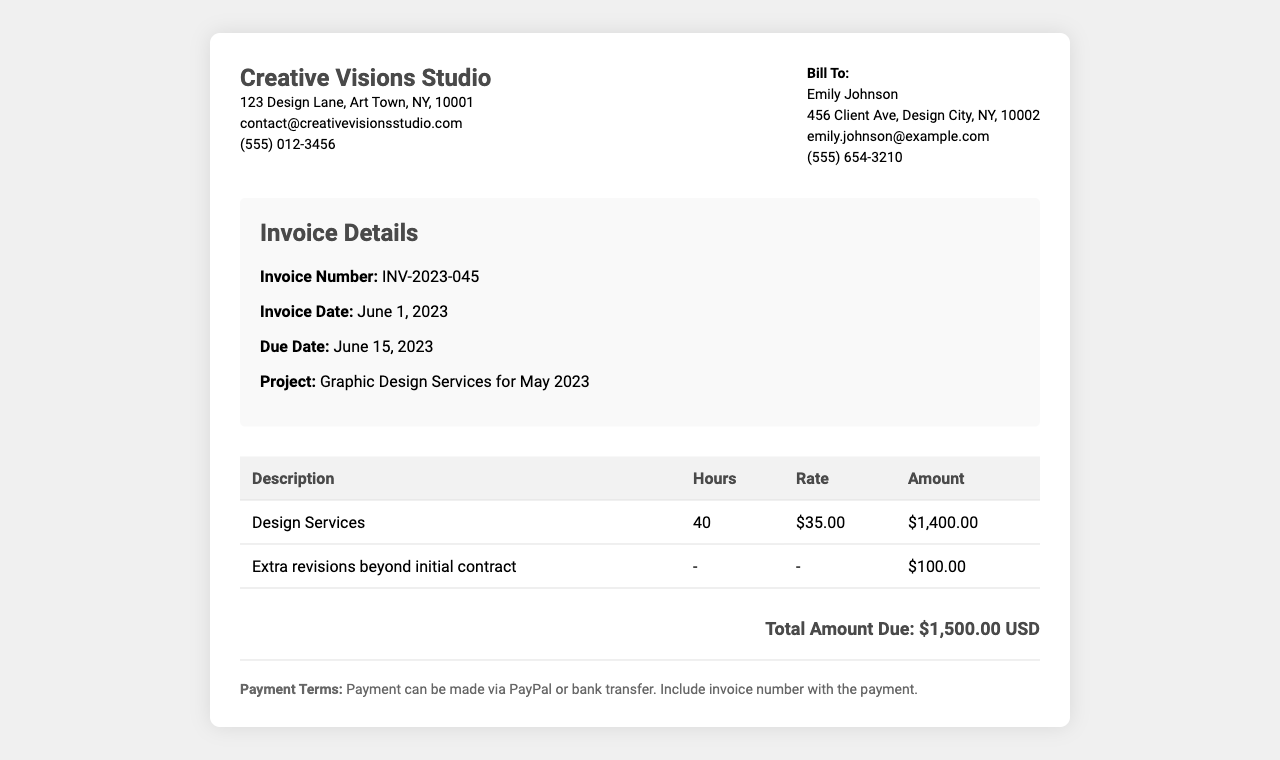What is the invoice number? The invoice number is specified in the document under "Invoice Details".
Answer: INV-2023-045 Who is the client? The client's name is listed in the "Bill To" section of the invoice.
Answer: Emily Johnson What is the due date of the invoice? The due date is mentioned in the "Invoice Details" section.
Answer: June 15, 2023 How many hours were worked for design services? The total hours for design services is shown in the table under "Hours".
Answer: 40 What is the hourly rate for design services? The rate for design services is specified in the table under "Rate".
Answer: $35.00 What is the total amount due? The total amount due is summarized at the bottom of the invoice.
Answer: $1,500.00 USD What additional charge is included in the invoice? The invoice lists an additional charge in the table, which is listed separately.
Answer: Extra revisions beyond initial contract What payment methods are accepted? The payment methods are outlined in the "Payment Terms" section of the invoice.
Answer: PayPal or bank transfer In which month were the graphic design services rendered? The services rendered are noted in the "Project" section of the invoice.
Answer: May 2023 